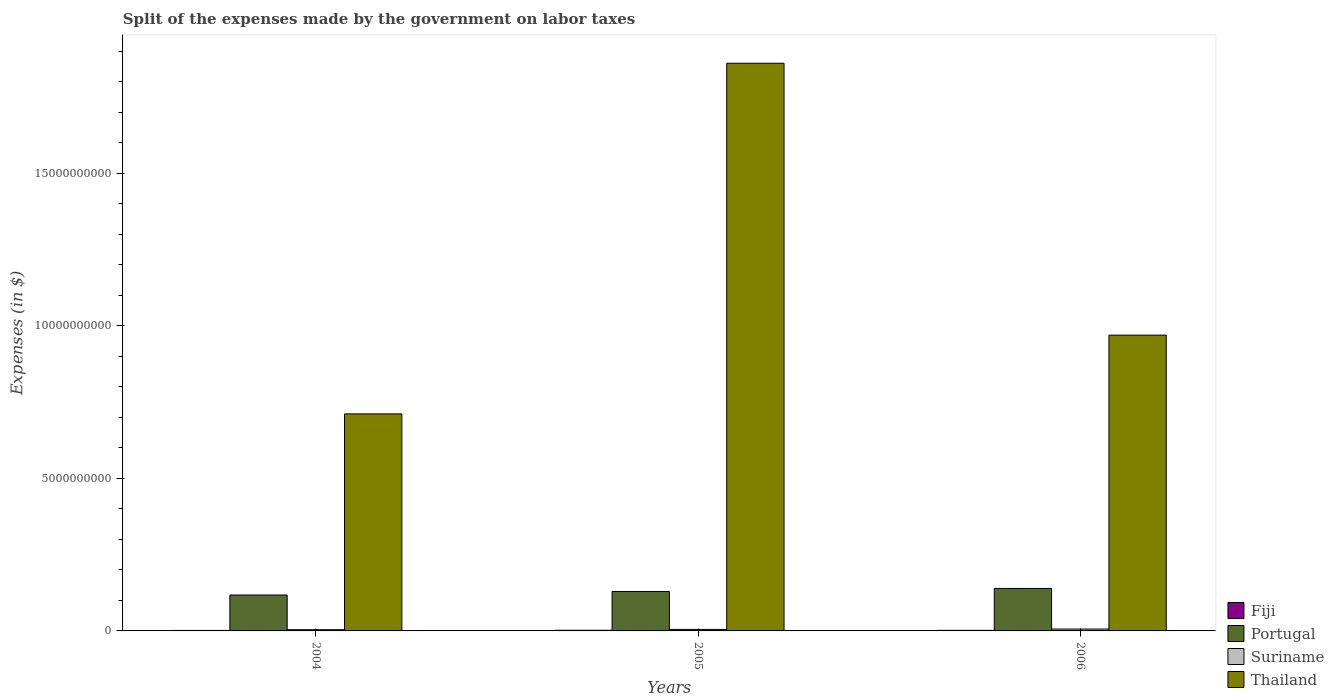How many groups of bars are there?
Your answer should be compact. 3. Are the number of bars per tick equal to the number of legend labels?
Ensure brevity in your answer.  Yes. Are the number of bars on each tick of the X-axis equal?
Your answer should be very brief. Yes. How many bars are there on the 3rd tick from the left?
Make the answer very short. 4. How many bars are there on the 2nd tick from the right?
Offer a terse response. 4. In how many cases, is the number of bars for a given year not equal to the number of legend labels?
Provide a short and direct response. 0. What is the expenses made by the government on labor taxes in Fiji in 2004?
Ensure brevity in your answer.  1.61e+07. Across all years, what is the maximum expenses made by the government on labor taxes in Fiji?
Provide a short and direct response. 2.17e+07. Across all years, what is the minimum expenses made by the government on labor taxes in Fiji?
Make the answer very short. 1.61e+07. In which year was the expenses made by the government on labor taxes in Thailand maximum?
Offer a very short reply. 2005. In which year was the expenses made by the government on labor taxes in Fiji minimum?
Provide a succinct answer. 2004. What is the total expenses made by the government on labor taxes in Portugal in the graph?
Make the answer very short. 3.87e+09. What is the difference between the expenses made by the government on labor taxes in Portugal in 2004 and that in 2006?
Give a very brief answer. -2.15e+08. What is the difference between the expenses made by the government on labor taxes in Thailand in 2005 and the expenses made by the government on labor taxes in Portugal in 2004?
Offer a terse response. 1.74e+1. What is the average expenses made by the government on labor taxes in Suriname per year?
Your response must be concise. 5.06e+07. In the year 2004, what is the difference between the expenses made by the government on labor taxes in Portugal and expenses made by the government on labor taxes in Thailand?
Ensure brevity in your answer.  -5.94e+09. In how many years, is the expenses made by the government on labor taxes in Fiji greater than 17000000000 $?
Your answer should be compact. 0. What is the ratio of the expenses made by the government on labor taxes in Portugal in 2004 to that in 2005?
Your response must be concise. 0.91. Is the difference between the expenses made by the government on labor taxes in Portugal in 2004 and 2006 greater than the difference between the expenses made by the government on labor taxes in Thailand in 2004 and 2006?
Provide a short and direct response. Yes. What is the difference between the highest and the second highest expenses made by the government on labor taxes in Portugal?
Give a very brief answer. 1.00e+08. What is the difference between the highest and the lowest expenses made by the government on labor taxes in Suriname?
Make the answer very short. 2.09e+07. In how many years, is the expenses made by the government on labor taxes in Thailand greater than the average expenses made by the government on labor taxes in Thailand taken over all years?
Provide a succinct answer. 1. Is the sum of the expenses made by the government on labor taxes in Thailand in 2004 and 2006 greater than the maximum expenses made by the government on labor taxes in Fiji across all years?
Offer a terse response. Yes. Is it the case that in every year, the sum of the expenses made by the government on labor taxes in Suriname and expenses made by the government on labor taxes in Thailand is greater than the sum of expenses made by the government on labor taxes in Portugal and expenses made by the government on labor taxes in Fiji?
Your answer should be very brief. No. What does the 2nd bar from the left in 2004 represents?
Keep it short and to the point. Portugal. What does the 2nd bar from the right in 2006 represents?
Provide a short and direct response. Suriname. How many years are there in the graph?
Offer a terse response. 3. What is the difference between two consecutive major ticks on the Y-axis?
Provide a short and direct response. 5.00e+09. Are the values on the major ticks of Y-axis written in scientific E-notation?
Offer a very short reply. No. Does the graph contain any zero values?
Keep it short and to the point. No. Does the graph contain grids?
Keep it short and to the point. No. How many legend labels are there?
Your answer should be compact. 4. What is the title of the graph?
Keep it short and to the point. Split of the expenses made by the government on labor taxes. Does "Upper middle income" appear as one of the legend labels in the graph?
Your answer should be very brief. No. What is the label or title of the X-axis?
Offer a very short reply. Years. What is the label or title of the Y-axis?
Provide a succinct answer. Expenses (in $). What is the Expenses (in $) in Fiji in 2004?
Keep it short and to the point. 1.61e+07. What is the Expenses (in $) of Portugal in 2004?
Keep it short and to the point. 1.18e+09. What is the Expenses (in $) of Suriname in 2004?
Your answer should be compact. 4.07e+07. What is the Expenses (in $) of Thailand in 2004?
Your answer should be compact. 7.12e+09. What is the Expenses (in $) of Fiji in 2005?
Offer a very short reply. 2.17e+07. What is the Expenses (in $) of Portugal in 2005?
Your answer should be very brief. 1.29e+09. What is the Expenses (in $) in Suriname in 2005?
Keep it short and to the point. 4.94e+07. What is the Expenses (in $) in Thailand in 2005?
Your answer should be very brief. 1.86e+1. What is the Expenses (in $) of Fiji in 2006?
Provide a succinct answer. 1.92e+07. What is the Expenses (in $) in Portugal in 2006?
Your answer should be compact. 1.39e+09. What is the Expenses (in $) in Suriname in 2006?
Your response must be concise. 6.16e+07. What is the Expenses (in $) in Thailand in 2006?
Provide a short and direct response. 9.70e+09. Across all years, what is the maximum Expenses (in $) of Fiji?
Your response must be concise. 2.17e+07. Across all years, what is the maximum Expenses (in $) in Portugal?
Your answer should be compact. 1.39e+09. Across all years, what is the maximum Expenses (in $) of Suriname?
Give a very brief answer. 6.16e+07. Across all years, what is the maximum Expenses (in $) in Thailand?
Make the answer very short. 1.86e+1. Across all years, what is the minimum Expenses (in $) in Fiji?
Offer a terse response. 1.61e+07. Across all years, what is the minimum Expenses (in $) of Portugal?
Your answer should be very brief. 1.18e+09. Across all years, what is the minimum Expenses (in $) in Suriname?
Keep it short and to the point. 4.07e+07. Across all years, what is the minimum Expenses (in $) in Thailand?
Your response must be concise. 7.12e+09. What is the total Expenses (in $) of Fiji in the graph?
Give a very brief answer. 5.69e+07. What is the total Expenses (in $) of Portugal in the graph?
Your answer should be compact. 3.87e+09. What is the total Expenses (in $) in Suriname in the graph?
Keep it short and to the point. 1.52e+08. What is the total Expenses (in $) in Thailand in the graph?
Your response must be concise. 3.54e+1. What is the difference between the Expenses (in $) of Fiji in 2004 and that in 2005?
Keep it short and to the point. -5.63e+06. What is the difference between the Expenses (in $) of Portugal in 2004 and that in 2005?
Offer a very short reply. -1.15e+08. What is the difference between the Expenses (in $) in Suriname in 2004 and that in 2005?
Offer a very short reply. -8.70e+06. What is the difference between the Expenses (in $) of Thailand in 2004 and that in 2005?
Keep it short and to the point. -1.15e+1. What is the difference between the Expenses (in $) in Fiji in 2004 and that in 2006?
Your answer should be compact. -3.12e+06. What is the difference between the Expenses (in $) of Portugal in 2004 and that in 2006?
Ensure brevity in your answer.  -2.15e+08. What is the difference between the Expenses (in $) in Suriname in 2004 and that in 2006?
Your response must be concise. -2.09e+07. What is the difference between the Expenses (in $) in Thailand in 2004 and that in 2006?
Provide a short and direct response. -2.58e+09. What is the difference between the Expenses (in $) of Fiji in 2005 and that in 2006?
Offer a terse response. 2.51e+06. What is the difference between the Expenses (in $) in Portugal in 2005 and that in 2006?
Offer a very short reply. -1.00e+08. What is the difference between the Expenses (in $) of Suriname in 2005 and that in 2006?
Provide a succinct answer. -1.22e+07. What is the difference between the Expenses (in $) of Thailand in 2005 and that in 2006?
Provide a short and direct response. 8.92e+09. What is the difference between the Expenses (in $) of Fiji in 2004 and the Expenses (in $) of Portugal in 2005?
Give a very brief answer. -1.28e+09. What is the difference between the Expenses (in $) of Fiji in 2004 and the Expenses (in $) of Suriname in 2005?
Ensure brevity in your answer.  -3.34e+07. What is the difference between the Expenses (in $) of Fiji in 2004 and the Expenses (in $) of Thailand in 2005?
Keep it short and to the point. -1.86e+1. What is the difference between the Expenses (in $) of Portugal in 2004 and the Expenses (in $) of Suriname in 2005?
Provide a short and direct response. 1.13e+09. What is the difference between the Expenses (in $) of Portugal in 2004 and the Expenses (in $) of Thailand in 2005?
Provide a succinct answer. -1.74e+1. What is the difference between the Expenses (in $) of Suriname in 2004 and the Expenses (in $) of Thailand in 2005?
Offer a very short reply. -1.86e+1. What is the difference between the Expenses (in $) of Fiji in 2004 and the Expenses (in $) of Portugal in 2006?
Make the answer very short. -1.38e+09. What is the difference between the Expenses (in $) of Fiji in 2004 and the Expenses (in $) of Suriname in 2006?
Offer a terse response. -4.55e+07. What is the difference between the Expenses (in $) of Fiji in 2004 and the Expenses (in $) of Thailand in 2006?
Your answer should be very brief. -9.68e+09. What is the difference between the Expenses (in $) in Portugal in 2004 and the Expenses (in $) in Suriname in 2006?
Make the answer very short. 1.12e+09. What is the difference between the Expenses (in $) in Portugal in 2004 and the Expenses (in $) in Thailand in 2006?
Ensure brevity in your answer.  -8.52e+09. What is the difference between the Expenses (in $) of Suriname in 2004 and the Expenses (in $) of Thailand in 2006?
Make the answer very short. -9.66e+09. What is the difference between the Expenses (in $) in Fiji in 2005 and the Expenses (in $) in Portugal in 2006?
Your answer should be very brief. -1.37e+09. What is the difference between the Expenses (in $) in Fiji in 2005 and the Expenses (in $) in Suriname in 2006?
Provide a succinct answer. -3.99e+07. What is the difference between the Expenses (in $) in Fiji in 2005 and the Expenses (in $) in Thailand in 2006?
Provide a succinct answer. -9.68e+09. What is the difference between the Expenses (in $) in Portugal in 2005 and the Expenses (in $) in Suriname in 2006?
Ensure brevity in your answer.  1.23e+09. What is the difference between the Expenses (in $) of Portugal in 2005 and the Expenses (in $) of Thailand in 2006?
Offer a terse response. -8.41e+09. What is the difference between the Expenses (in $) in Suriname in 2005 and the Expenses (in $) in Thailand in 2006?
Provide a short and direct response. -9.65e+09. What is the average Expenses (in $) of Fiji per year?
Keep it short and to the point. 1.90e+07. What is the average Expenses (in $) of Portugal per year?
Provide a succinct answer. 1.29e+09. What is the average Expenses (in $) of Suriname per year?
Your response must be concise. 5.06e+07. What is the average Expenses (in $) in Thailand per year?
Your response must be concise. 1.18e+1. In the year 2004, what is the difference between the Expenses (in $) in Fiji and Expenses (in $) in Portugal?
Keep it short and to the point. -1.16e+09. In the year 2004, what is the difference between the Expenses (in $) in Fiji and Expenses (in $) in Suriname?
Give a very brief answer. -2.47e+07. In the year 2004, what is the difference between the Expenses (in $) of Fiji and Expenses (in $) of Thailand?
Offer a terse response. -7.10e+09. In the year 2004, what is the difference between the Expenses (in $) of Portugal and Expenses (in $) of Suriname?
Ensure brevity in your answer.  1.14e+09. In the year 2004, what is the difference between the Expenses (in $) of Portugal and Expenses (in $) of Thailand?
Your answer should be very brief. -5.94e+09. In the year 2004, what is the difference between the Expenses (in $) in Suriname and Expenses (in $) in Thailand?
Your answer should be compact. -7.08e+09. In the year 2005, what is the difference between the Expenses (in $) in Fiji and Expenses (in $) in Portugal?
Provide a succinct answer. -1.27e+09. In the year 2005, what is the difference between the Expenses (in $) of Fiji and Expenses (in $) of Suriname?
Keep it short and to the point. -2.77e+07. In the year 2005, what is the difference between the Expenses (in $) in Fiji and Expenses (in $) in Thailand?
Offer a terse response. -1.86e+1. In the year 2005, what is the difference between the Expenses (in $) of Portugal and Expenses (in $) of Suriname?
Give a very brief answer. 1.24e+09. In the year 2005, what is the difference between the Expenses (in $) in Portugal and Expenses (in $) in Thailand?
Your response must be concise. -1.73e+1. In the year 2005, what is the difference between the Expenses (in $) of Suriname and Expenses (in $) of Thailand?
Offer a very short reply. -1.86e+1. In the year 2006, what is the difference between the Expenses (in $) of Fiji and Expenses (in $) of Portugal?
Your response must be concise. -1.37e+09. In the year 2006, what is the difference between the Expenses (in $) in Fiji and Expenses (in $) in Suriname?
Give a very brief answer. -4.24e+07. In the year 2006, what is the difference between the Expenses (in $) of Fiji and Expenses (in $) of Thailand?
Provide a succinct answer. -9.68e+09. In the year 2006, what is the difference between the Expenses (in $) in Portugal and Expenses (in $) in Suriname?
Provide a short and direct response. 1.33e+09. In the year 2006, what is the difference between the Expenses (in $) of Portugal and Expenses (in $) of Thailand?
Your answer should be compact. -8.31e+09. In the year 2006, what is the difference between the Expenses (in $) of Suriname and Expenses (in $) of Thailand?
Make the answer very short. -9.64e+09. What is the ratio of the Expenses (in $) of Fiji in 2004 to that in 2005?
Your answer should be very brief. 0.74. What is the ratio of the Expenses (in $) of Portugal in 2004 to that in 2005?
Provide a short and direct response. 0.91. What is the ratio of the Expenses (in $) of Suriname in 2004 to that in 2005?
Provide a short and direct response. 0.82. What is the ratio of the Expenses (in $) of Thailand in 2004 to that in 2005?
Your response must be concise. 0.38. What is the ratio of the Expenses (in $) in Fiji in 2004 to that in 2006?
Give a very brief answer. 0.84. What is the ratio of the Expenses (in $) of Portugal in 2004 to that in 2006?
Provide a short and direct response. 0.85. What is the ratio of the Expenses (in $) of Suriname in 2004 to that in 2006?
Ensure brevity in your answer.  0.66. What is the ratio of the Expenses (in $) of Thailand in 2004 to that in 2006?
Provide a succinct answer. 0.73. What is the ratio of the Expenses (in $) of Fiji in 2005 to that in 2006?
Make the answer very short. 1.13. What is the ratio of the Expenses (in $) of Portugal in 2005 to that in 2006?
Your response must be concise. 0.93. What is the ratio of the Expenses (in $) of Suriname in 2005 to that in 2006?
Ensure brevity in your answer.  0.8. What is the ratio of the Expenses (in $) of Thailand in 2005 to that in 2006?
Your answer should be compact. 1.92. What is the difference between the highest and the second highest Expenses (in $) in Fiji?
Your answer should be compact. 2.51e+06. What is the difference between the highest and the second highest Expenses (in $) in Portugal?
Give a very brief answer. 1.00e+08. What is the difference between the highest and the second highest Expenses (in $) of Suriname?
Keep it short and to the point. 1.22e+07. What is the difference between the highest and the second highest Expenses (in $) of Thailand?
Ensure brevity in your answer.  8.92e+09. What is the difference between the highest and the lowest Expenses (in $) of Fiji?
Make the answer very short. 5.63e+06. What is the difference between the highest and the lowest Expenses (in $) in Portugal?
Make the answer very short. 2.15e+08. What is the difference between the highest and the lowest Expenses (in $) of Suriname?
Provide a succinct answer. 2.09e+07. What is the difference between the highest and the lowest Expenses (in $) of Thailand?
Provide a succinct answer. 1.15e+1. 